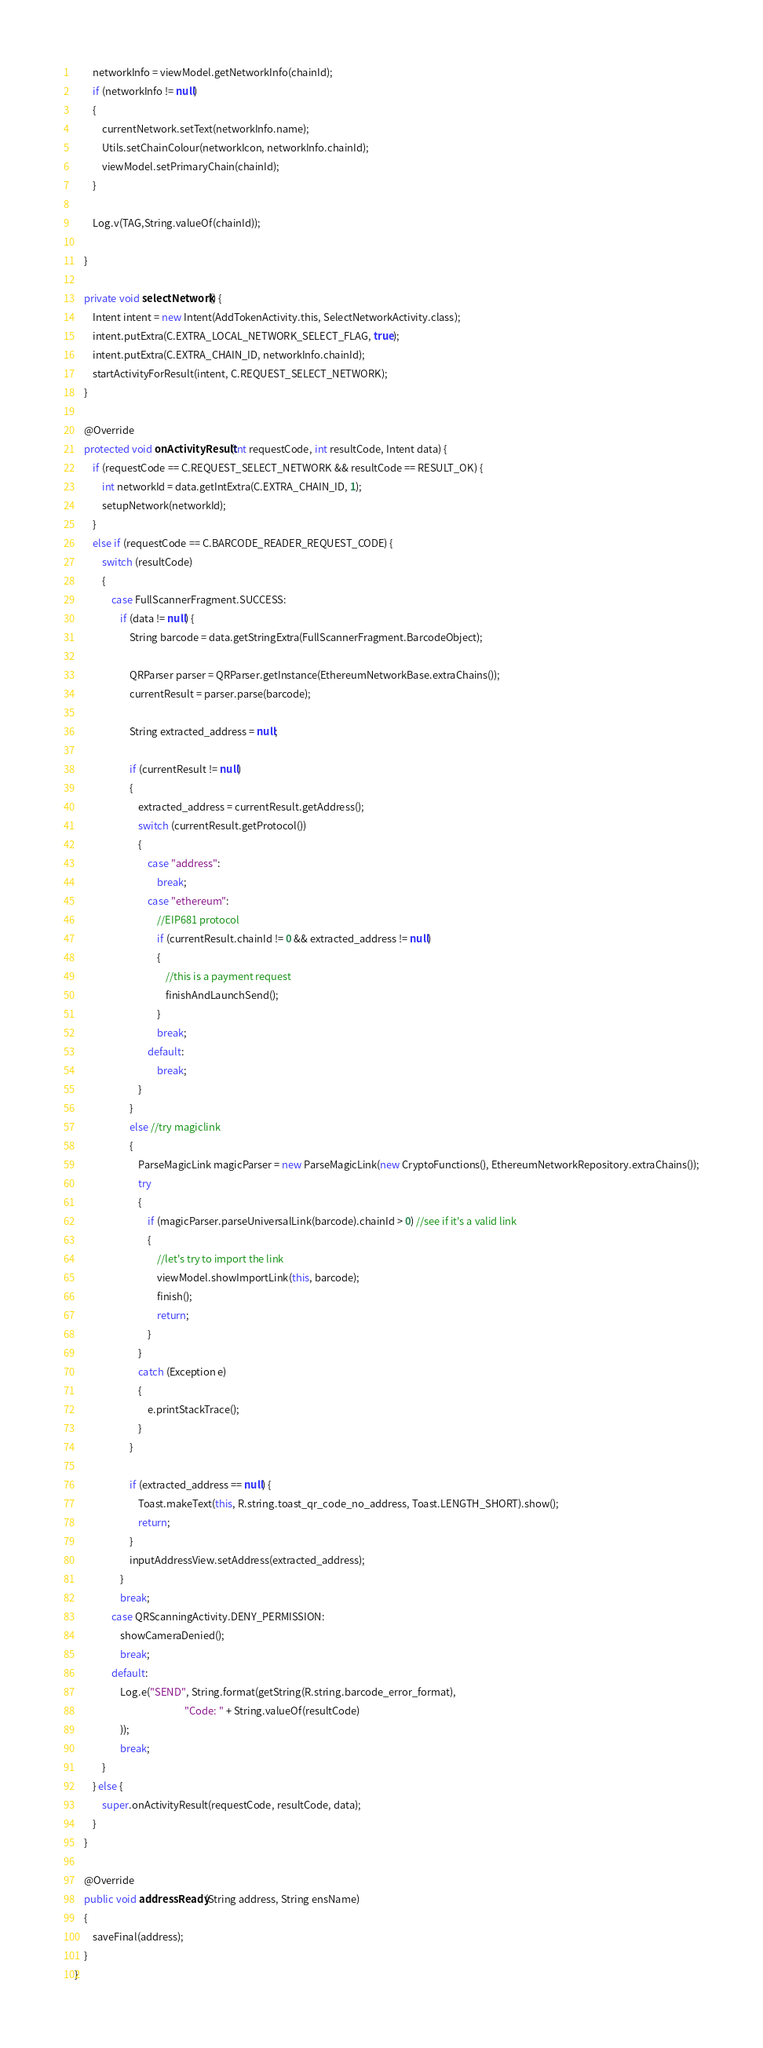Convert code to text. <code><loc_0><loc_0><loc_500><loc_500><_Java_>        networkInfo = viewModel.getNetworkInfo(chainId);
        if (networkInfo != null)
        {
            currentNetwork.setText(networkInfo.name);
            Utils.setChainColour(networkIcon, networkInfo.chainId);
            viewModel.setPrimaryChain(chainId);
        }

        Log.v(TAG,String.valueOf(chainId));

    }

    private void selectNetwork() {
        Intent intent = new Intent(AddTokenActivity.this, SelectNetworkActivity.class);
        intent.putExtra(C.EXTRA_LOCAL_NETWORK_SELECT_FLAG, true);
        intent.putExtra(C.EXTRA_CHAIN_ID, networkInfo.chainId);
        startActivityForResult(intent, C.REQUEST_SELECT_NETWORK);
    }

    @Override
    protected void onActivityResult(int requestCode, int resultCode, Intent data) {
        if (requestCode == C.REQUEST_SELECT_NETWORK && resultCode == RESULT_OK) {
            int networkId = data.getIntExtra(C.EXTRA_CHAIN_ID, 1);
            setupNetwork(networkId);
        }
        else if (requestCode == C.BARCODE_READER_REQUEST_CODE) {
            switch (resultCode)
            {
                case FullScannerFragment.SUCCESS:
                    if (data != null) {
                        String barcode = data.getStringExtra(FullScannerFragment.BarcodeObject);

                        QRParser parser = QRParser.getInstance(EthereumNetworkBase.extraChains());
                        currentResult = parser.parse(barcode);

                        String extracted_address = null;

                        if (currentResult != null)
                        {
                            extracted_address = currentResult.getAddress();
                            switch (currentResult.getProtocol())
                            {
                                case "address":
                                    break;
                                case "ethereum":
                                    //EIP681 protocol
                                    if (currentResult.chainId != 0 && extracted_address != null)
                                    {
                                        //this is a payment request
                                        finishAndLaunchSend();
                                    }
                                    break;
                                default:
                                    break;
                            }
                        }
                        else //try magiclink
                        {
                            ParseMagicLink magicParser = new ParseMagicLink(new CryptoFunctions(), EthereumNetworkRepository.extraChains());
                            try
                            {
                                if (magicParser.parseUniversalLink(barcode).chainId > 0) //see if it's a valid link
                                {
                                    //let's try to import the link
                                    viewModel.showImportLink(this, barcode);
                                    finish();
                                    return;
                                }
                            }
                            catch (Exception e)
                            {
                                e.printStackTrace();
                            }
                        }

                        if (extracted_address == null) {
                            Toast.makeText(this, R.string.toast_qr_code_no_address, Toast.LENGTH_SHORT).show();
                            return;
                        }
                        inputAddressView.setAddress(extracted_address);
                    }
                    break;
                case QRScanningActivity.DENY_PERMISSION:
                    showCameraDenied();
                    break;
                default:
                    Log.e("SEND", String.format(getString(R.string.barcode_error_format),
                                                "Code: " + String.valueOf(resultCode)
                    ));
                    break;
            }
        } else {
            super.onActivityResult(requestCode, resultCode, data);
        }
    }

    @Override
    public void addressReady(String address, String ensName)
    {
        saveFinal(address);
    }
}
</code> 